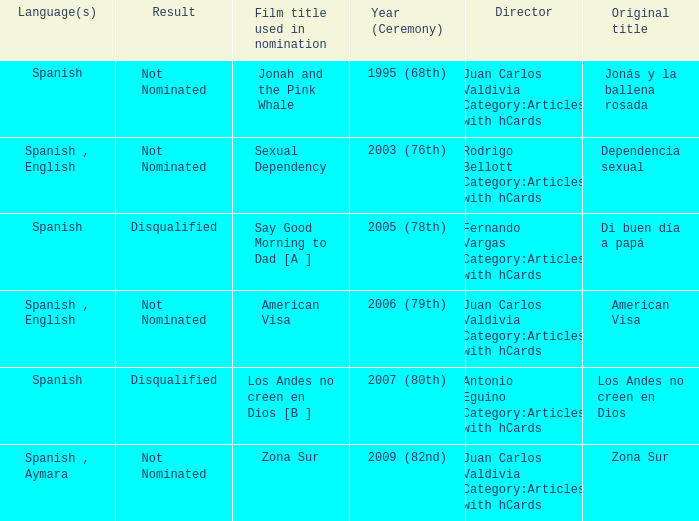What is Dependencia Sexual's film title that was used in its nomination? Sexual Dependency. 